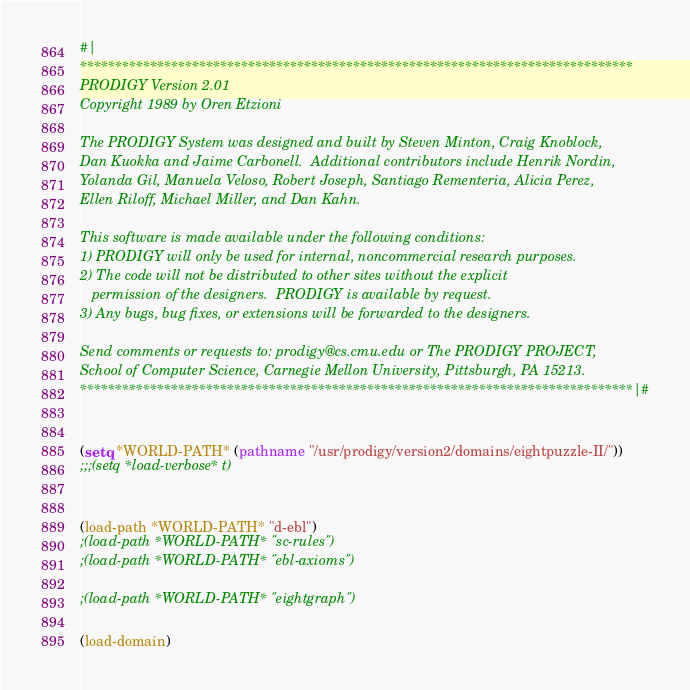<code> <loc_0><loc_0><loc_500><loc_500><_Lisp_>#|
*******************************************************************************
PRODIGY Version 2.01  
Copyright 1989 by Oren Etzioni

The PRODIGY System was designed and built by Steven Minton, Craig Knoblock,
Dan Kuokka and Jaime Carbonell.  Additional contributors include Henrik Nordin,
Yolanda Gil, Manuela Veloso, Robert Joseph, Santiago Rementeria, Alicia Perez, 
Ellen Riloff, Michael Miller, and Dan Kahn.

This software is made available under the following conditions:
1) PRODIGY will only be used for internal, noncommercial research purposes.
2) The code will not be distributed to other sites without the explicit 
   permission of the designers.  PRODIGY is available by request.
3) Any bugs, bug fixes, or extensions will be forwarded to the designers. 

Send comments or requests to: prodigy@cs.cmu.edu or The PRODIGY PROJECT,
School of Computer Science, Carnegie Mellon University, Pittsburgh, PA 15213.
*******************************************************************************|#


(setq *WORLD-PATH* (pathname "/usr/prodigy/version2/domains/eightpuzzle-II/"))
;;;(setq *load-verbose* t)


(load-path *WORLD-PATH* "d-ebl")
;(load-path *WORLD-PATH* "sc-rules")
;(load-path *WORLD-PATH* "ebl-axioms")

;(load-path *WORLD-PATH* "eightgraph")

(load-domain)

</code> 